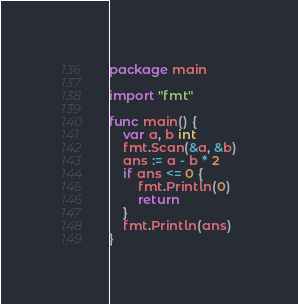<code> <loc_0><loc_0><loc_500><loc_500><_Go_>package main

import "fmt"

func main() {
	var a, b int
	fmt.Scan(&a, &b)
	ans := a - b * 2
	if ans <= 0 {
		fmt.Println(0)
		return
	}
	fmt.Println(ans)
}
</code> 